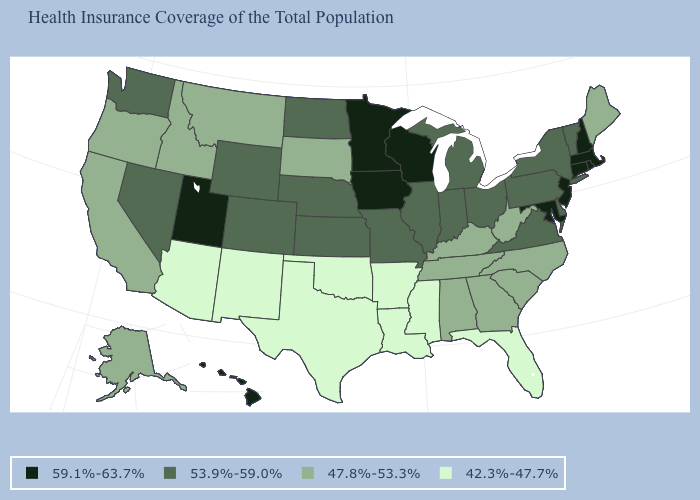What is the value of Maine?
Answer briefly. 47.8%-53.3%. What is the lowest value in the USA?
Quick response, please. 42.3%-47.7%. Among the states that border West Virginia , does Maryland have the highest value?
Quick response, please. Yes. What is the value of Virginia?
Short answer required. 53.9%-59.0%. Which states have the highest value in the USA?
Write a very short answer. Connecticut, Hawaii, Iowa, Maryland, Massachusetts, Minnesota, New Hampshire, New Jersey, Rhode Island, Utah, Wisconsin. What is the highest value in the USA?
Keep it brief. 59.1%-63.7%. How many symbols are there in the legend?
Concise answer only. 4. What is the lowest value in the South?
Quick response, please. 42.3%-47.7%. What is the lowest value in states that border California?
Quick response, please. 42.3%-47.7%. Does Connecticut have the lowest value in the Northeast?
Answer briefly. No. Does Utah have the same value as Connecticut?
Short answer required. Yes. What is the value of Oklahoma?
Give a very brief answer. 42.3%-47.7%. Does Virginia have a higher value than Texas?
Write a very short answer. Yes. What is the value of Alaska?
Answer briefly. 47.8%-53.3%. What is the value of West Virginia?
Concise answer only. 47.8%-53.3%. 